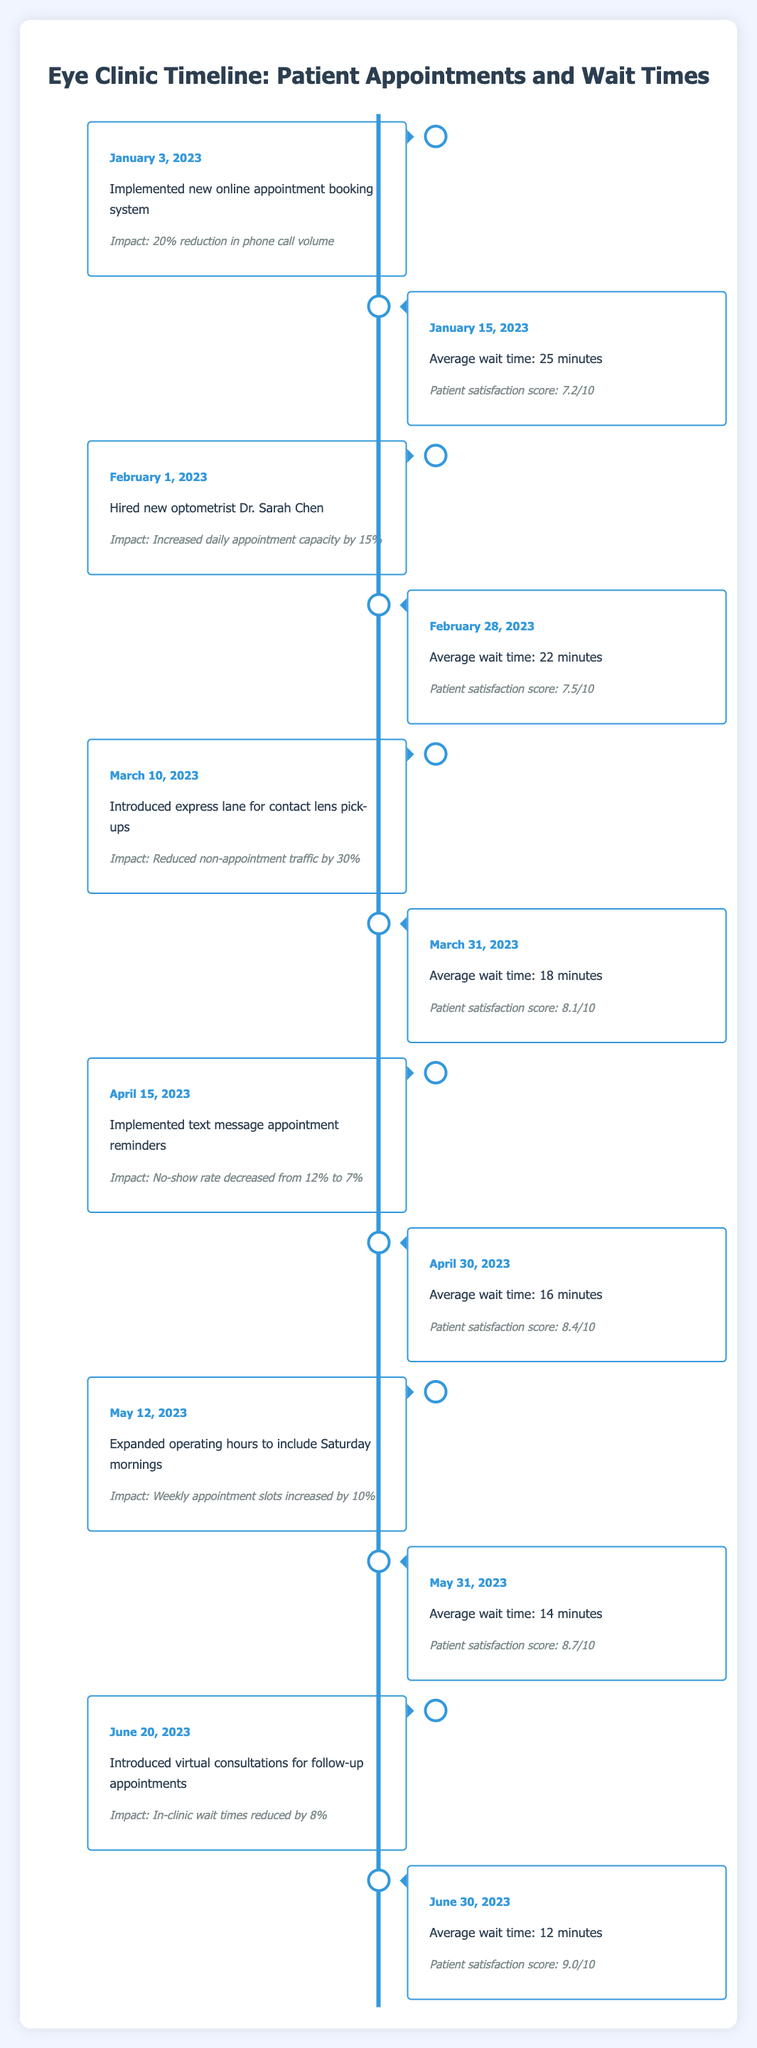What event occurred on January 15, 2023? The event listed for January 15, 2023, is the average wait time, which was 25 minutes.
Answer: Average wait time: 25 minutes What is the average wait time on June 30, 2023? According to the table, the average wait time on June 30, 2023, is explicitly stated as 12 minutes.
Answer: Average wait time: 12 minutes Did the patient satisfaction score increase from January to March? In January, the satisfaction score was 7.2, and in March, it was 8.1. Since 8.1 is greater than 7.2, the score did indeed increase.
Answer: Yes What was the impact of hiring Dr. Sarah Chen on daily appointment capacity? The entry for February 1, 2023, states that hiring Dr. Sarah Chen increased daily appointment capacity by 15%.
Answer: Increased daily appointment capacity by 15% What was the decrease in the no-show rate after implementing text message reminders on April 15, 2023? Before the text message reminders, the no-show rate was 12%, and after implementation, it decreased to 7%. The difference is calculated as 12% - 7%, which equals a decrease of 5 percentage points.
Answer: Decrease of 5 percentage points What was the average wait time trend over the six months? The data shows the average wait times decreasing from 25 minutes in January to 12 minutes in June. This indicates a continuous downward trend in wait times, enhancing patient experience. This can be summarized as a decreasing trend of 25 to 12 minutes.
Answer: Decreasing trend Which month had the highest patient satisfaction score, and what was the score? The highest patient satisfaction score recorded in the table is 9.0/10 on June 30, 2023. Looking through the scores from each month, June has the highest score.
Answer: June, score: 9.0/10 What was the average wait time after implementing the express lane on March 10, 2023? After the introduction of the express lane on March 10, 2023, the next recorded average wait time was 18 minutes on March 31, demonstrating an improvement in wait times.
Answer: Average wait time: 18 minutes What was the impact of introducing virtual consultations on wait times? The introduction of virtual consultations on June 20, 2023, reduced in-clinic wait times by 8%. This implies that the overall efficiency of patient flow improved due to virtual consultations.
Answer: Reduced by 8% 